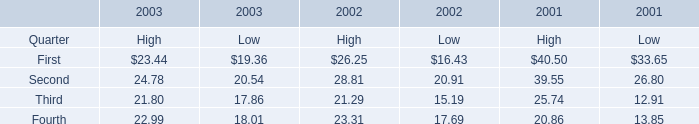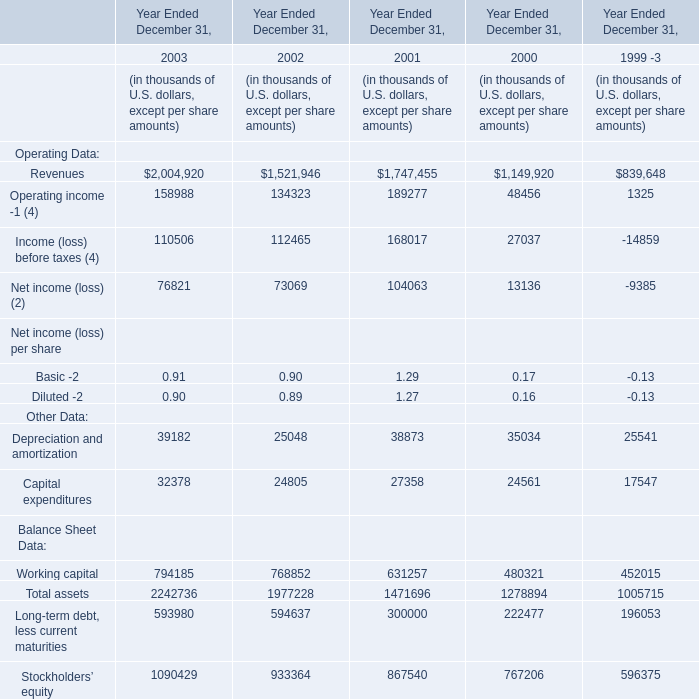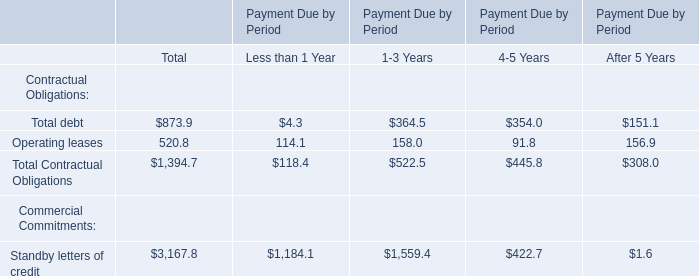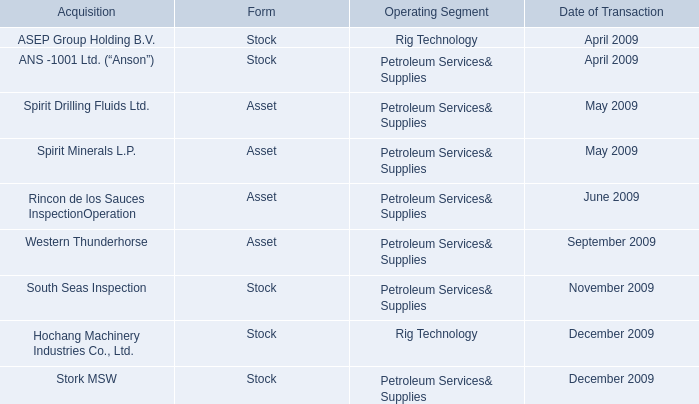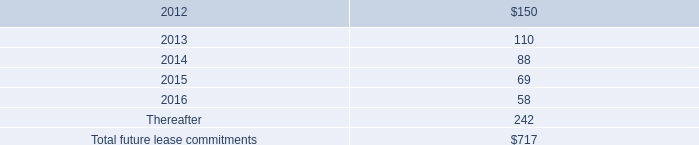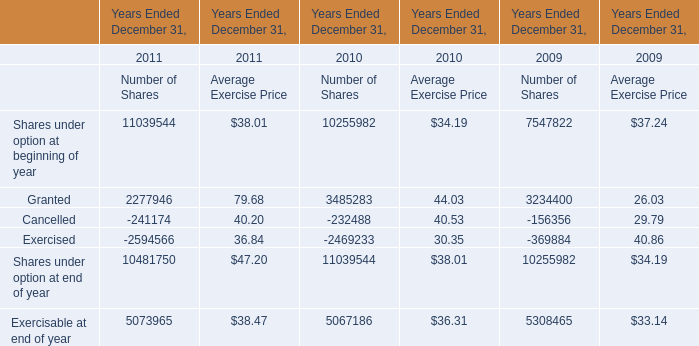What will First for Low reach in 2004 if it continues to grow at its current rate? 
Computations: (19.36 * (1 + ((19.36 - 16.43) / 16.43)))
Answer: 22.81251. 